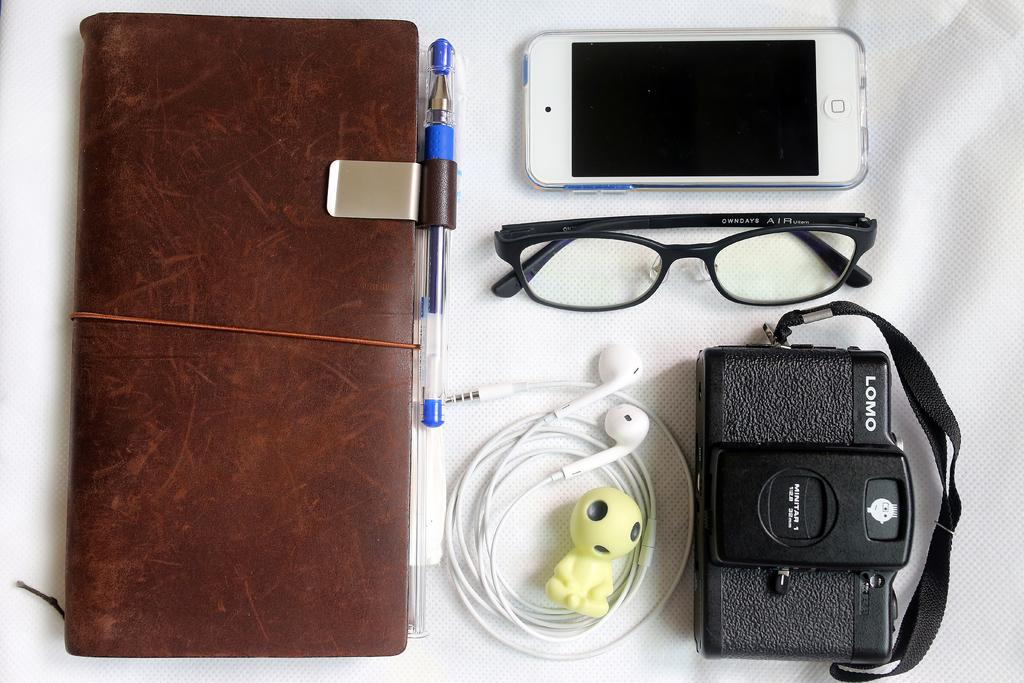What is one of the objects visible in the image? There is a book in the image. What is another object that can be seen in the image? There is a pen in the image. What device is also present in the image? There is a mobile in the image. What is the fourth object visible in the image? There is a camera in the image. Can you describe the other objects present in the image? There are other objects in the image, but their specific details are not mentioned in the provided facts. What is the color of the surface on which the objects are placed? The objects are placed on a white color surface. How many units of cake are present in the image? There is no mention of cakes in the provided facts, so it cannot be determined if any units of cake are present in the image. What type of force is being exerted on the objects in the image? There is no information about any force being exerted on the objects in the image, so it cannot be determined. 